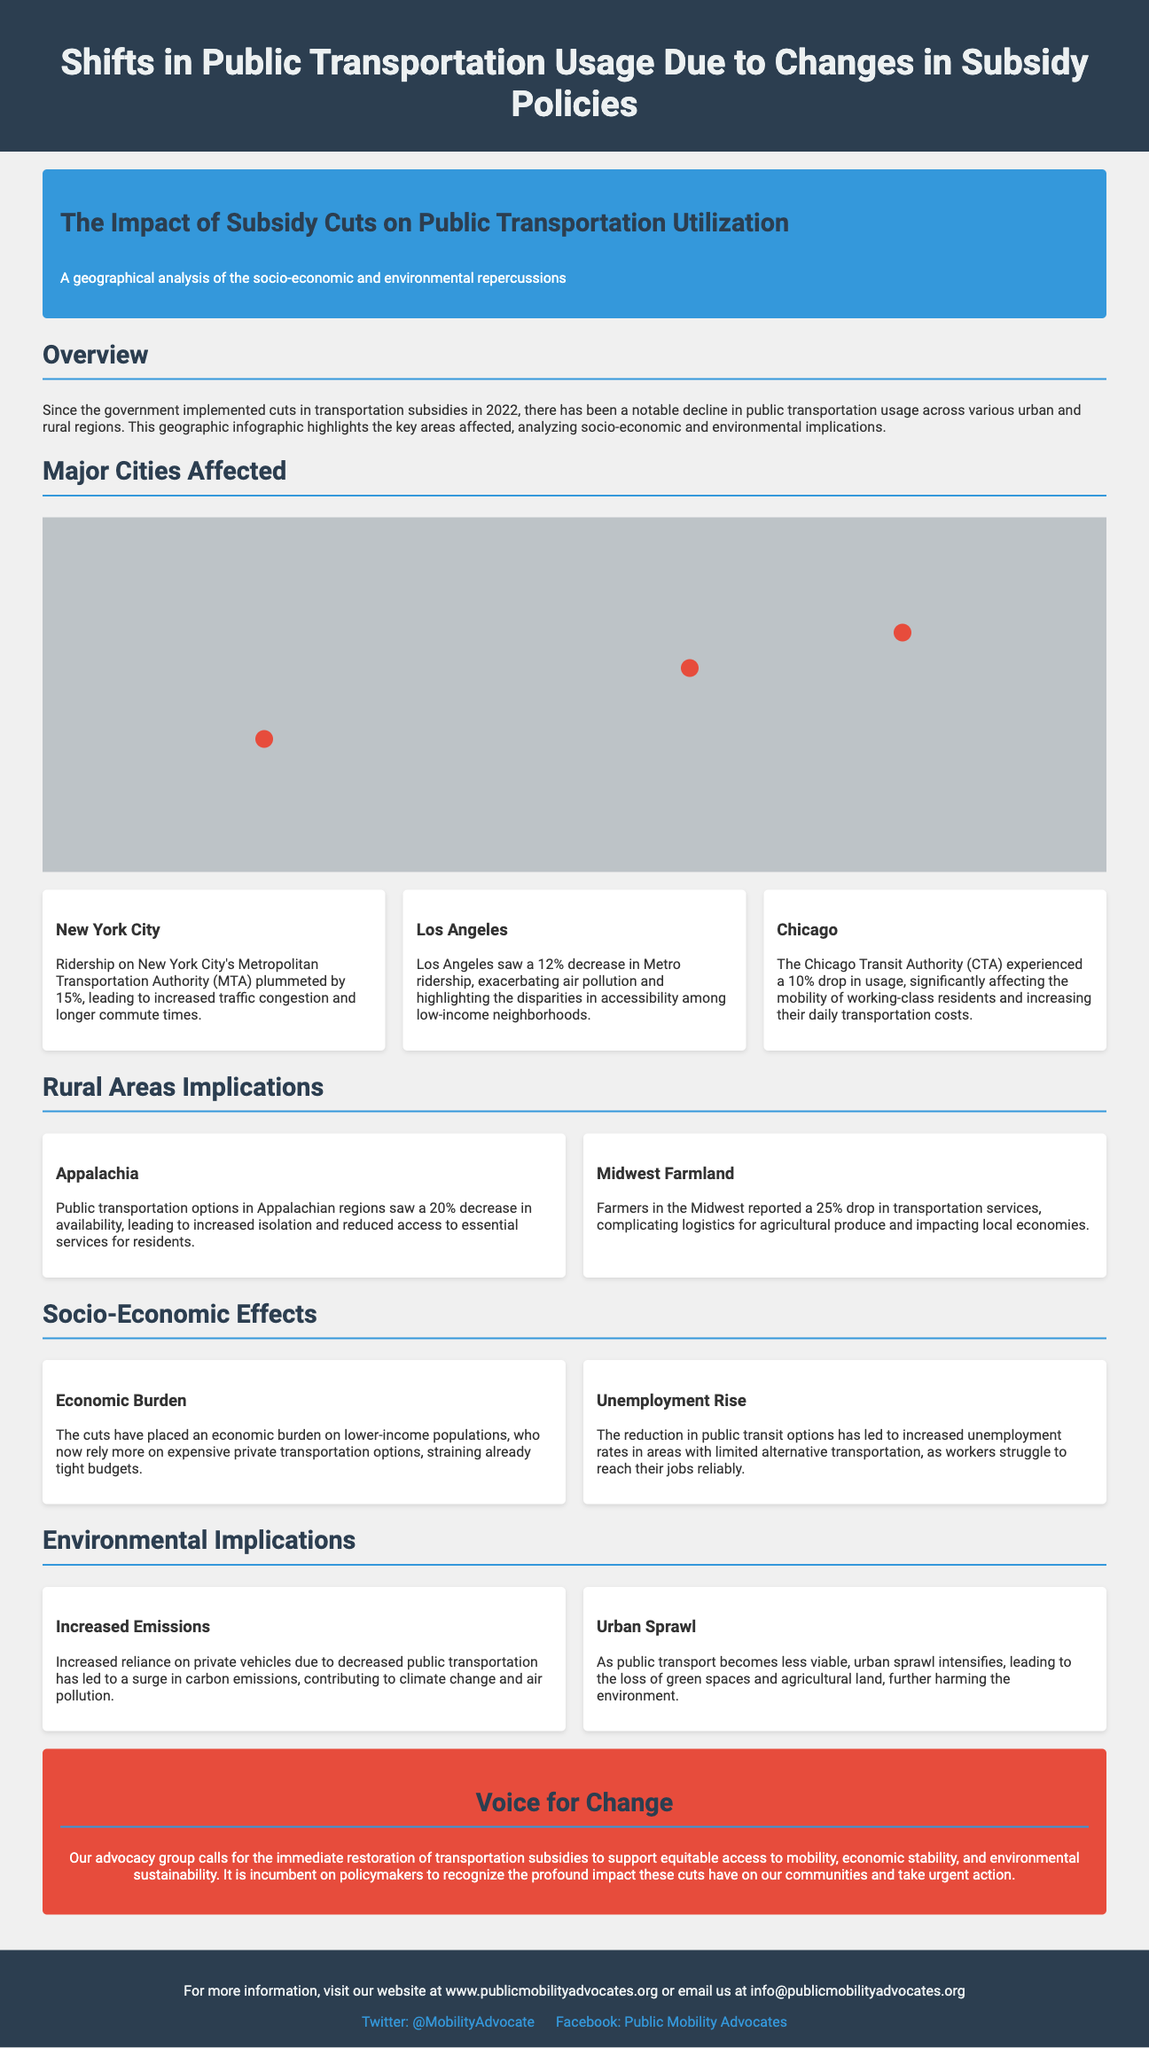What percentage did New York City's ridership decrease? The infographic states that New York City's ridership decreased by 15%.
Answer: 15% What was the percentage decrease in transportation service availability in Appalachia? The document mentions a 20% decrease in public transportation options in Appalachian regions.
Answer: 20% Which city experienced a 10% drop in CTA usage? According to the infographic, Chicago experienced a 10% drop in usage.
Answer: Chicago What socio-economic effect is discussed in relation to increased reliance on private transportation? The document indicates that relying more on expensive private transportation places an economic burden on lower-income populations.
Answer: Economic burden How much did Metro ridership drop in Los Angeles? The infographic specifies that Los Angeles saw a 12% decrease in Metro ridership.
Answer: 12% What long-term environmental implication is mentioned due to decreased public transport? The document highlights that decreased public transportation contributes to urban sprawl.
Answer: Urban sprawl What year did the government implement cuts in transportation subsidies? The overview section notes that the cuts were implemented in 2022.
Answer: 2022 What is the call to action mentioned at the end of the document? The advocacy group's call to action emphasizes the immediate restoration of transportation subsidies.
Answer: Restoration of transportation subsidies 